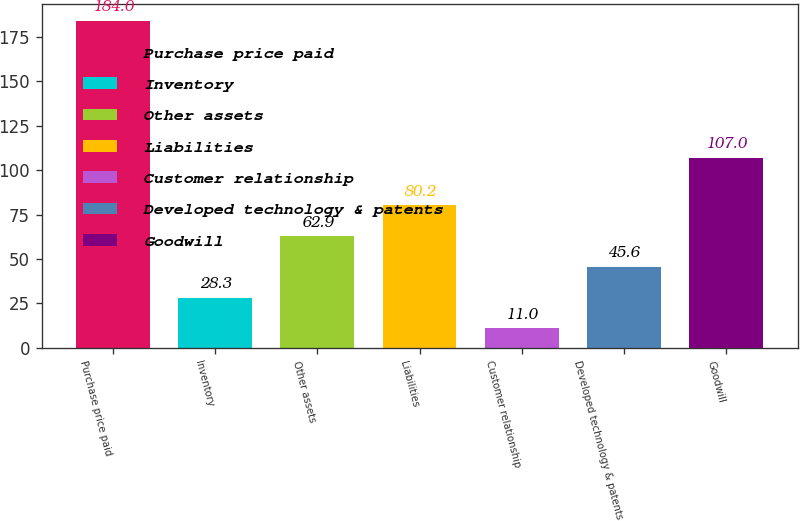Convert chart. <chart><loc_0><loc_0><loc_500><loc_500><bar_chart><fcel>Purchase price paid<fcel>Inventory<fcel>Other assets<fcel>Liabilities<fcel>Customer relationship<fcel>Developed technology & patents<fcel>Goodwill<nl><fcel>184<fcel>28.3<fcel>62.9<fcel>80.2<fcel>11<fcel>45.6<fcel>107<nl></chart> 